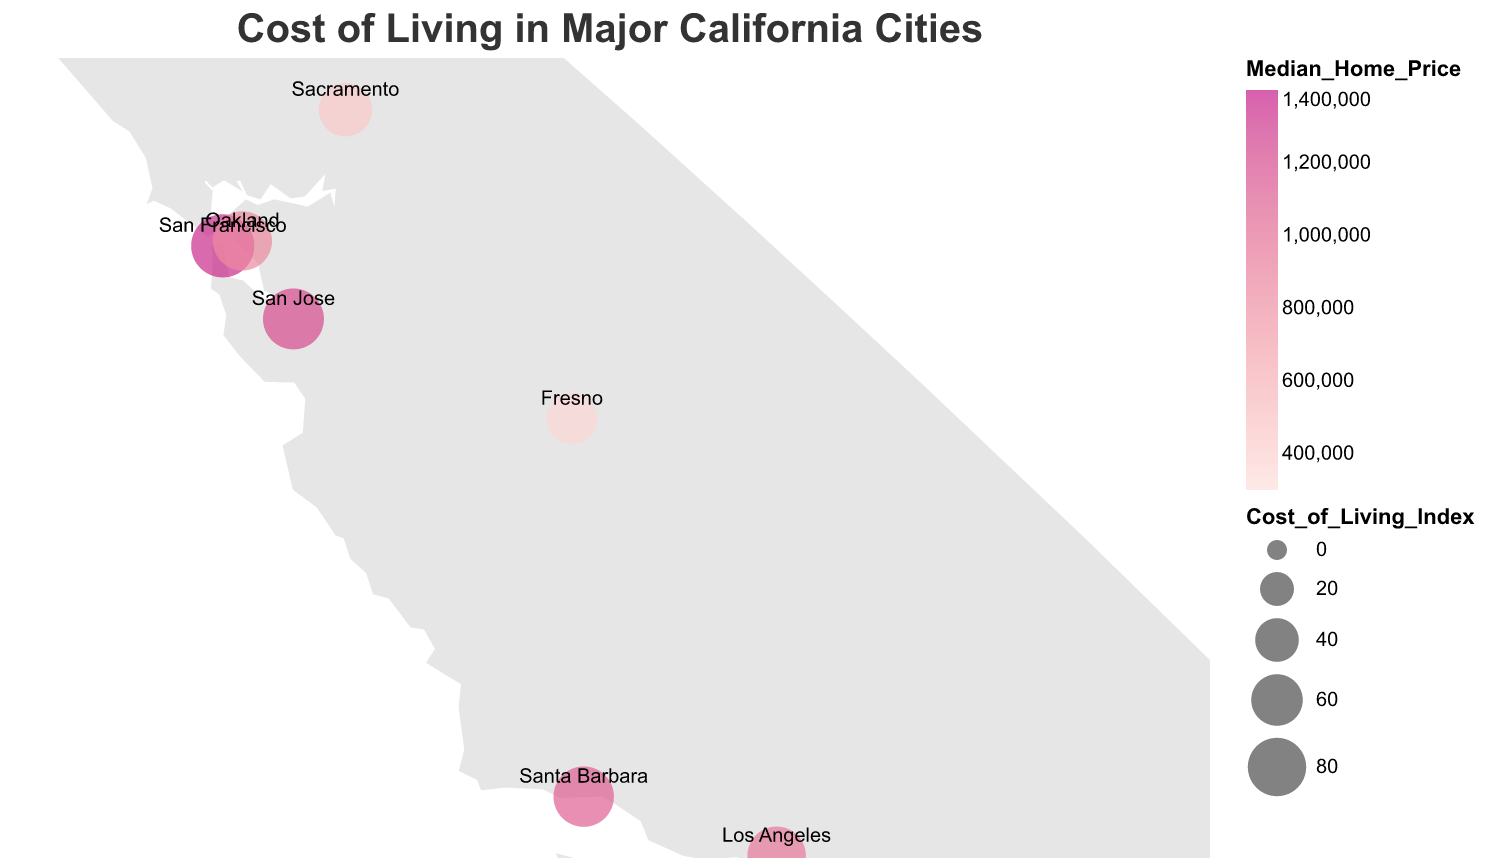Which city has the highest median rent for a 1-bedroom apartment? San Francisco's dot has the largest tooltip value for Median Rent (1BR), showing $3,100.
Answer: San Francisco Which city has the lowest cost of living index? Fresno's dot is the smallest compared to others, indicating it has the lowest Cost of Living Index value at 58.9.
Answer: Fresno Which city has a higher cost of living index, Sacramento or San Diego? Comparing the sizes of the circles, San Diego's dot is larger than Sacramento’s, which indicates a higher Cost of Living Index value.
Answer: San Diego What is the total median home price of Long Beach and Anaheim? Long Beach's median home price is $750,000 and Anaheim's median home price is $800,000. Adding them together, $750,000 + $800,000 = $1,550,000.
Answer: $1,550,000 Which city has the most expensive median home price after San Francisco? The color intensity representing the median home price indicates San Francisco (most expensive), followed by San Jose with $1,200,000.
Answer: San Jose What is the difference in median rent for a 1-bedroom apartment between Fresno and Oakland? Fresno’s median rent is $1,050 and Oakland’s is $2,400. The difference is $2,400 - $1,050 = $1,350.
Answer: $1,350 Which city ranks second in terms of the cost of living index? San Francisco's index is the highest at 95.7. The next largest dot corresponds to San Jose with an index of 88.3.
Answer: San Jose What is the average median rent for a 1-bedroom apartment in San Jose, Long Beach, and Santa Barbara? Average rent is calculated as ($2,700 + $1,800 + $2,300) / 3. Sum = $6,800. Average = $6,800 / 3 = $2,266.67.
Answer: $2,266.67 Is it cheaper to buy a home in Sacramento or Fresno? Fresno's color is lighter than Sacramento's, indicating a lower median home price of $350,000 compared to Sacramento’s $450,000.
Answer: Fresno 